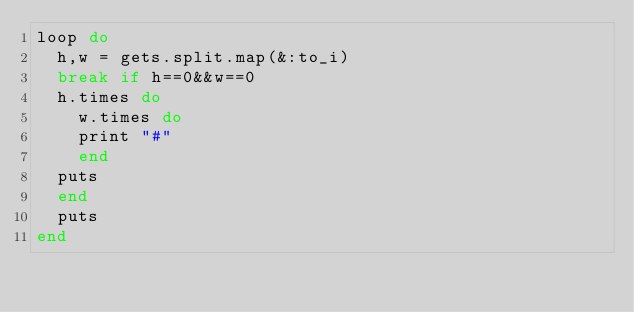<code> <loc_0><loc_0><loc_500><loc_500><_Ruby_>loop do
  h,w = gets.split.map(&:to_i)
  break if h==0&&w==0
  h.times do
    w.times do
    print "#"
    end
  puts
  end
  puts
end
</code> 